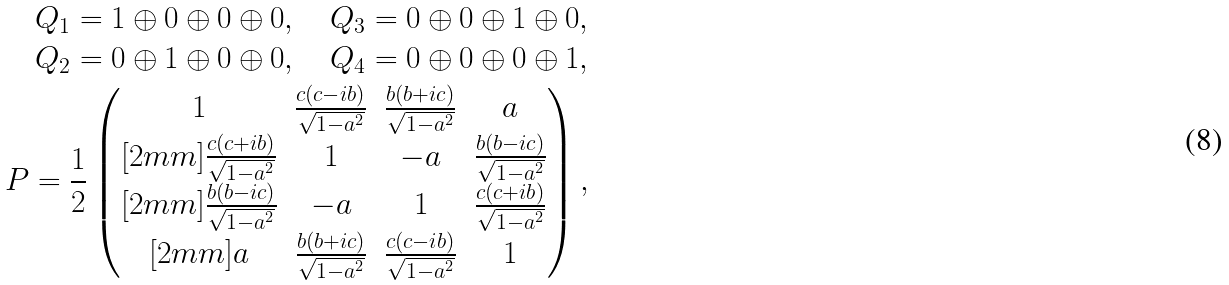Convert formula to latex. <formula><loc_0><loc_0><loc_500><loc_500>Q _ { 1 } = 1 \oplus 0 \oplus 0 \oplus 0 , \quad Q _ { 3 } = 0 \oplus 0 \oplus 1 \oplus 0 , \\ Q _ { 2 } = 0 \oplus 1 \oplus 0 \oplus 0 , \quad Q _ { 4 } = 0 \oplus 0 \oplus 0 \oplus 1 , \\ P = \frac { 1 } { 2 } \begin{pmatrix} 1 & \frac { c ( c - i b ) } { \sqrt { 1 - a ^ { 2 } } } & \frac { b ( b + i c ) } { \sqrt { 1 - a ^ { 2 } } } & a \\ [ 2 m m ] \frac { c ( c + i b ) } { \sqrt { 1 - a ^ { 2 } } } & 1 & - a & \frac { b ( b - i c ) } { \sqrt { 1 - a ^ { 2 } } } \\ [ 2 m m ] \frac { b ( b - i c ) } { \sqrt { 1 - a ^ { 2 } } } & - a & 1 & \frac { c ( c + i b ) } { \sqrt { 1 - a ^ { 2 } } } \\ [ 2 m m ] a & \frac { b ( b + i c ) } { \sqrt { 1 - a ^ { 2 } } } & \frac { c ( c - i b ) } { \sqrt { 1 - a ^ { 2 } } } & 1 \end{pmatrix} ,</formula> 